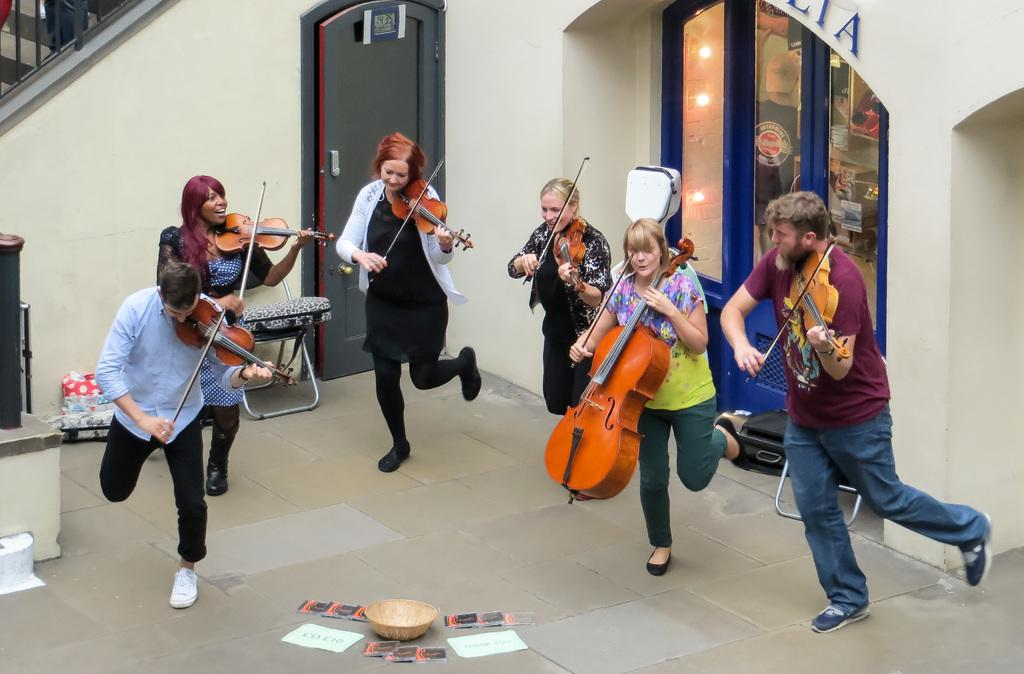How many people are in the image? There are six persons in the image. What are the persons doing in the image? The persons are standing and holding violins, and they are playing the violins. What can be seen in the center of the image? There is a basket in the center of the image. What architectural features can be seen in the background of the image? There is a wall and a door in the background of the image. What is located in the left corner of the image? There is a staircase in the left corner of the image. What religious beliefs are being discussed in the image? There is no indication of any religious beliefs being discussed in the image; it features six persons playing violins. What story is being told by the persons in the image? There is no story being told by the persons in the image; they are simply playing their violins. 